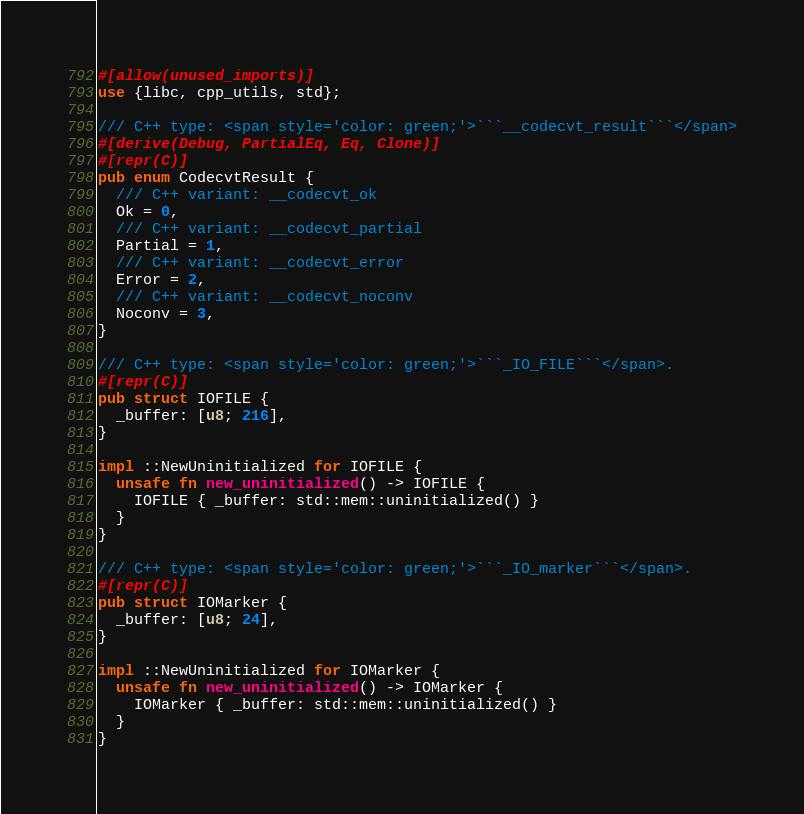<code> <loc_0><loc_0><loc_500><loc_500><_Rust_>#[allow(unused_imports)]
use {libc, cpp_utils, std};

/// C++ type: <span style='color: green;'>```__codecvt_result```</span>
#[derive(Debug, PartialEq, Eq, Clone)]
#[repr(C)]
pub enum CodecvtResult {
  /// C++ variant: __codecvt_ok
  Ok = 0,
  /// C++ variant: __codecvt_partial
  Partial = 1,
  /// C++ variant: __codecvt_error
  Error = 2,
  /// C++ variant: __codecvt_noconv
  Noconv = 3,
}

/// C++ type: <span style='color: green;'>```_IO_FILE```</span>.
#[repr(C)]
pub struct IOFILE {
  _buffer: [u8; 216],
}

impl ::NewUninitialized for IOFILE {
  unsafe fn new_uninitialized() -> IOFILE {
    IOFILE { _buffer: std::mem::uninitialized() }
  }
}

/// C++ type: <span style='color: green;'>```_IO_marker```</span>.
#[repr(C)]
pub struct IOMarker {
  _buffer: [u8; 24],
}

impl ::NewUninitialized for IOMarker {
  unsafe fn new_uninitialized() -> IOMarker {
    IOMarker { _buffer: std::mem::uninitialized() }
  }
}
</code> 